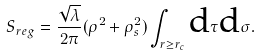<formula> <loc_0><loc_0><loc_500><loc_500>S _ { r e g } = \frac { \sqrt { \lambda } } { 2 \pi } ( \rho ^ { 2 } + \rho ^ { 2 } _ { s } ) \int _ { r \geq r _ { c } } \text {d} \tau \text {d} \sigma .</formula> 